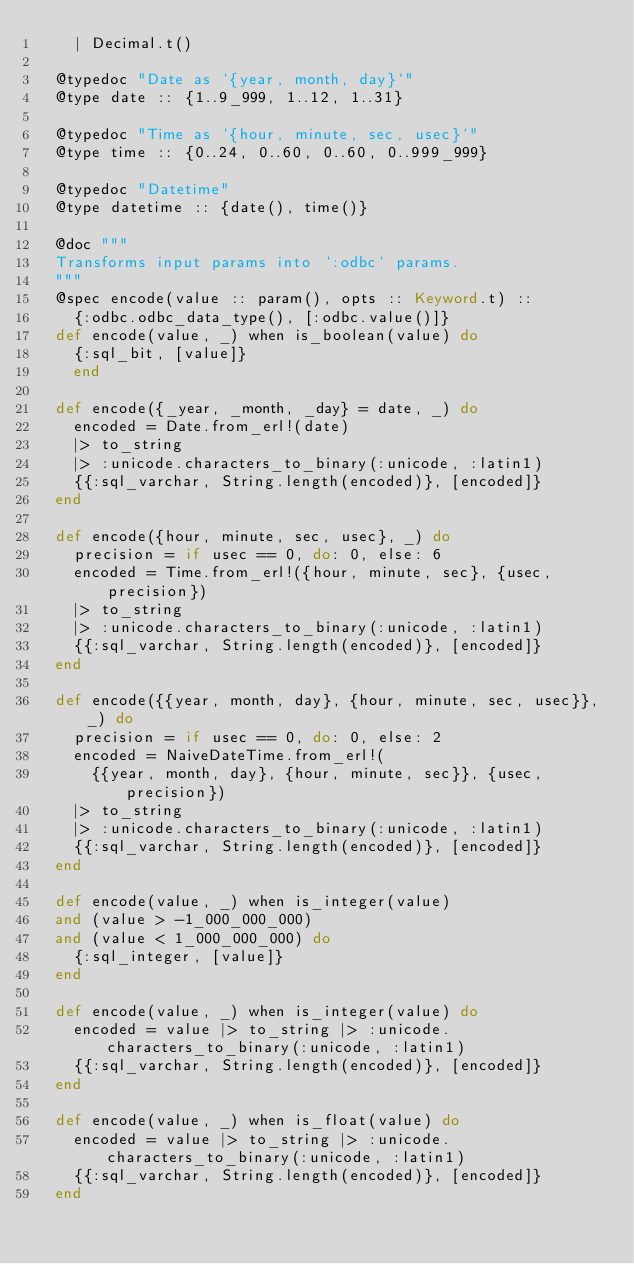Convert code to text. <code><loc_0><loc_0><loc_500><loc_500><_Elixir_>    | Decimal.t()

  @typedoc "Date as `{year, month, day}`"
  @type date :: {1..9_999, 1..12, 1..31}

  @typedoc "Time as `{hour, minute, sec, usec}`"
  @type time :: {0..24, 0..60, 0..60, 0..999_999}

  @typedoc "Datetime"
  @type datetime :: {date(), time()}

  @doc """
  Transforms input params into `:odbc` params.
  """
  @spec encode(value :: param(), opts :: Keyword.t) ::
    {:odbc.odbc_data_type(), [:odbc.value()]}
  def encode(value, _) when is_boolean(value) do
    {:sql_bit, [value]}
    end

  def encode({_year, _month, _day} = date, _) do
    encoded = Date.from_erl!(date)
    |> to_string
    |> :unicode.characters_to_binary(:unicode, :latin1)
    {{:sql_varchar, String.length(encoded)}, [encoded]}
  end

  def encode({hour, minute, sec, usec}, _) do
    precision = if usec == 0, do: 0, else: 6
    encoded = Time.from_erl!({hour, minute, sec}, {usec, precision})
    |> to_string
    |> :unicode.characters_to_binary(:unicode, :latin1)
    {{:sql_varchar, String.length(encoded)}, [encoded]}
  end

  def encode({{year, month, day}, {hour, minute, sec, usec}}, _) do
    precision = if usec == 0, do: 0, else: 2
    encoded = NaiveDateTime.from_erl!(
      {{year, month, day}, {hour, minute, sec}}, {usec, precision})
    |> to_string
    |> :unicode.characters_to_binary(:unicode, :latin1)
    {{:sql_varchar, String.length(encoded)}, [encoded]}
  end

  def encode(value, _) when is_integer(value)
  and (value > -1_000_000_000)
  and (value < 1_000_000_000) do
    {:sql_integer, [value]}
  end

  def encode(value, _) when is_integer(value) do
    encoded = value |> to_string |> :unicode.characters_to_binary(:unicode, :latin1)
    {{:sql_varchar, String.length(encoded)}, [encoded]}
  end

  def encode(value, _) when is_float(value) do
    encoded = value |> to_string |> :unicode.characters_to_binary(:unicode, :latin1)
    {{:sql_varchar, String.length(encoded)}, [encoded]}
  end
</code> 